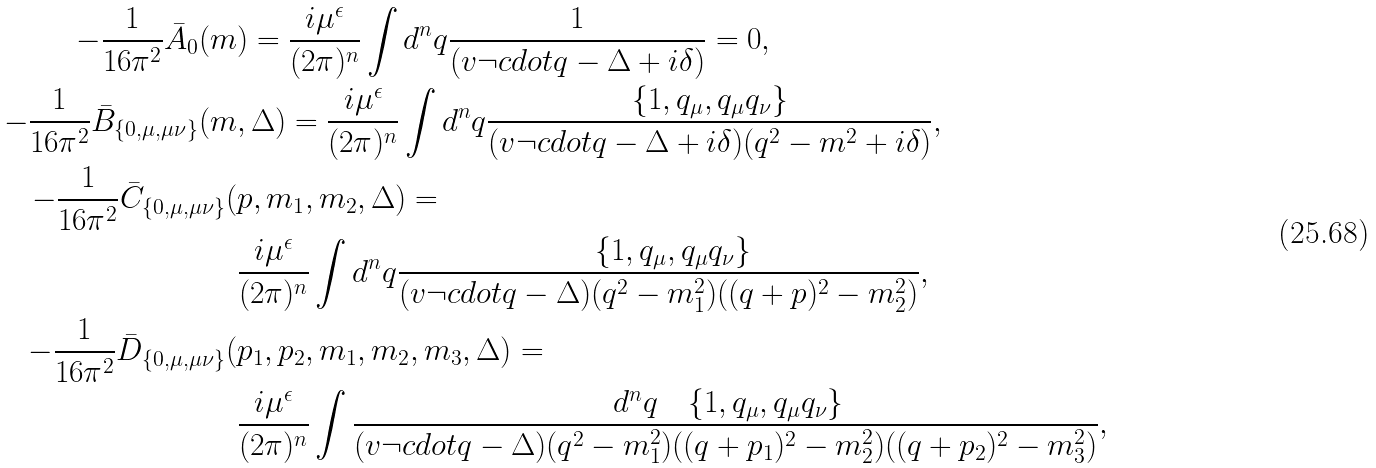Convert formula to latex. <formula><loc_0><loc_0><loc_500><loc_500>- \frac { 1 } { 1 6 \pi ^ { 2 } } \bar { A } _ { 0 } ( m & ) = \frac { i \mu ^ { \epsilon } } { ( 2 \pi ) ^ { n } } \int d ^ { n } q \frac { 1 } { ( v \neg c d o t q - \Delta + i \delta ) } = 0 , \\ - \frac { 1 } { 1 6 \pi ^ { 2 } } \bar { B } _ { \{ 0 , \mu , \mu \nu \} } ( m & , \Delta ) = \frac { i \mu ^ { \epsilon } } { ( 2 \pi ) ^ { n } } \int d ^ { n } q \frac { \{ 1 , q _ { \mu } , q _ { \mu } q _ { \nu } \} } { ( v \neg c d o t q - \Delta + i \delta ) ( q ^ { 2 } - m ^ { 2 } + i \delta ) } , \\ - \frac { 1 } { 1 6 \pi ^ { 2 } } \bar { C } _ { \{ 0 , \mu , \mu \nu \} } ( & p , m _ { 1 } , m _ { 2 } , \Delta ) = \\ & \frac { i \mu ^ { \epsilon } } { ( 2 \pi ) ^ { n } } \int d ^ { n } q \frac { \quad \{ 1 , q _ { \mu } , q _ { \mu } q _ { \nu } \} } { ( v \neg c d o t q - \Delta ) ( q ^ { 2 } - m _ { 1 } ^ { 2 } ) ( ( q + p ) ^ { 2 } - m _ { 2 } ^ { 2 } ) } , \\ - \frac { 1 } { 1 6 \pi ^ { 2 } } \bar { D } _ { \{ 0 , \mu , \mu \nu \} } ( & p _ { 1 } , p _ { 2 } , m _ { 1 } , m _ { 2 } , m _ { 3 } , \Delta ) = \\ & \frac { i \mu ^ { \epsilon } } { ( 2 \pi ) ^ { n } } \int \frac { \, d ^ { n } q \quad \{ 1 , q _ { \mu } , q _ { \mu } q _ { \nu } \} } { ( v \neg c d o t q - \Delta ) ( q ^ { 2 } - m _ { 1 } ^ { 2 } ) ( ( q + p _ { 1 } ) ^ { 2 } - m _ { 2 } ^ { 2 } ) ( ( q + p _ { 2 } ) ^ { 2 } - m _ { 3 } ^ { 2 } ) } ,</formula> 